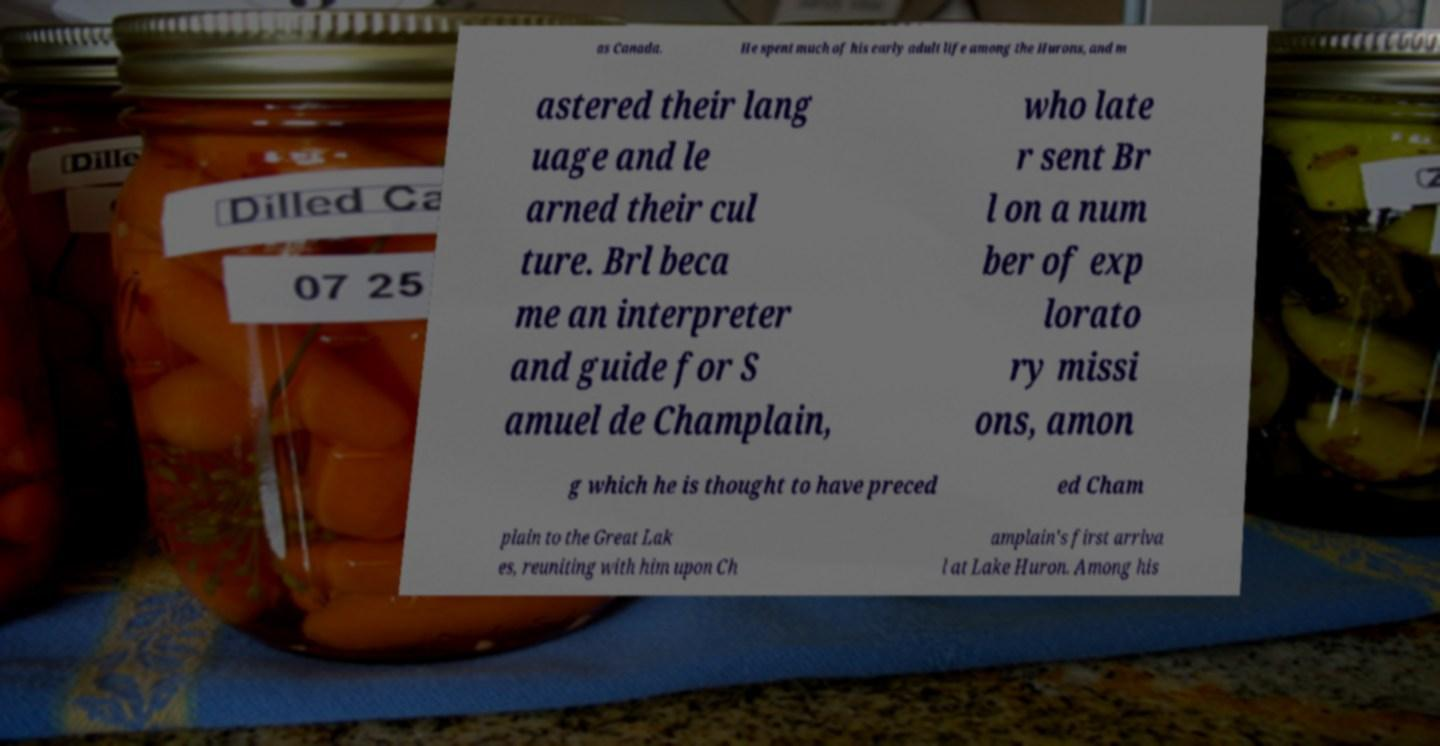Please identify and transcribe the text found in this image. as Canada. He spent much of his early adult life among the Hurons, and m astered their lang uage and le arned their cul ture. Brl beca me an interpreter and guide for S amuel de Champlain, who late r sent Br l on a num ber of exp lorato ry missi ons, amon g which he is thought to have preced ed Cham plain to the Great Lak es, reuniting with him upon Ch amplain's first arriva l at Lake Huron. Among his 